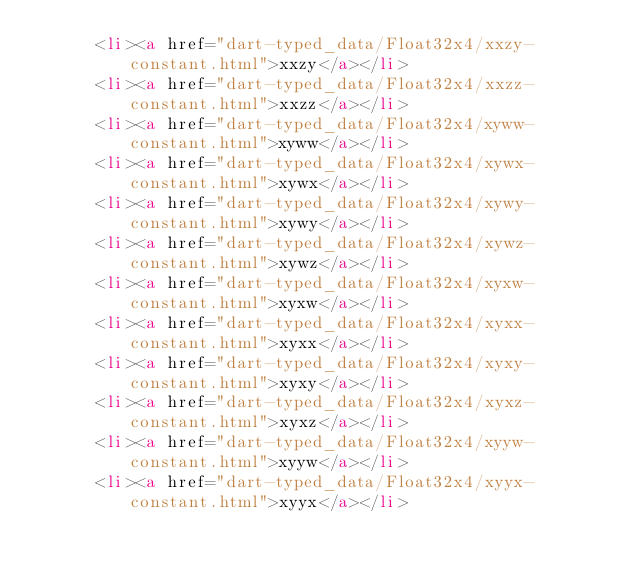<code> <loc_0><loc_0><loc_500><loc_500><_HTML_>      <li><a href="dart-typed_data/Float32x4/xxzy-constant.html">xxzy</a></li>
      <li><a href="dart-typed_data/Float32x4/xxzz-constant.html">xxzz</a></li>
      <li><a href="dart-typed_data/Float32x4/xyww-constant.html">xyww</a></li>
      <li><a href="dart-typed_data/Float32x4/xywx-constant.html">xywx</a></li>
      <li><a href="dart-typed_data/Float32x4/xywy-constant.html">xywy</a></li>
      <li><a href="dart-typed_data/Float32x4/xywz-constant.html">xywz</a></li>
      <li><a href="dart-typed_data/Float32x4/xyxw-constant.html">xyxw</a></li>
      <li><a href="dart-typed_data/Float32x4/xyxx-constant.html">xyxx</a></li>
      <li><a href="dart-typed_data/Float32x4/xyxy-constant.html">xyxy</a></li>
      <li><a href="dart-typed_data/Float32x4/xyxz-constant.html">xyxz</a></li>
      <li><a href="dart-typed_data/Float32x4/xyyw-constant.html">xyyw</a></li>
      <li><a href="dart-typed_data/Float32x4/xyyx-constant.html">xyyx</a></li></code> 